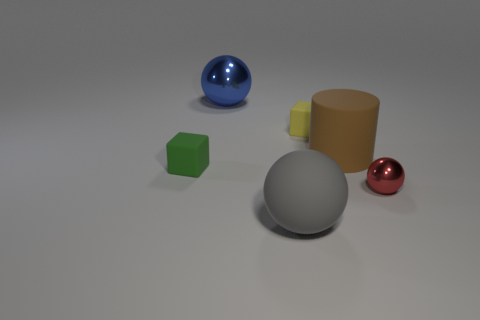Are there the same number of small shiny things in front of the large brown thing and red things in front of the yellow cube?
Give a very brief answer. Yes. What number of other objects are the same material as the yellow thing?
Give a very brief answer. 3. What number of shiny things are brown cylinders or blocks?
Keep it short and to the point. 0. Does the tiny matte object right of the big blue metallic object have the same shape as the green matte object?
Provide a short and direct response. Yes. Is the number of spheres that are to the left of the gray thing greater than the number of big cyan rubber balls?
Provide a short and direct response. Yes. What number of objects are both on the right side of the large gray sphere and behind the red object?
Ensure brevity in your answer.  2. What is the color of the metallic object behind the tiny rubber cube right of the gray rubber sphere?
Offer a very short reply. Blue. Is the color of the big metallic thing the same as the cube that is to the right of the blue object?
Your response must be concise. No. Is the number of small green matte spheres less than the number of large metal spheres?
Offer a terse response. Yes. Are there more balls that are to the left of the red object than large gray rubber balls that are right of the big brown matte thing?
Provide a short and direct response. Yes. 